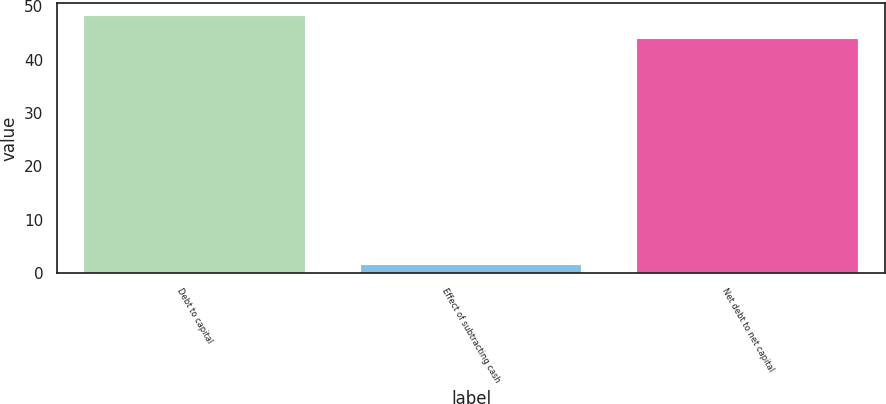Convert chart to OTSL. <chart><loc_0><loc_0><loc_500><loc_500><bar_chart><fcel>Debt to capital<fcel>Effect of subtracting cash<fcel>Net debt to net capital<nl><fcel>48.18<fcel>1.5<fcel>43.8<nl></chart> 